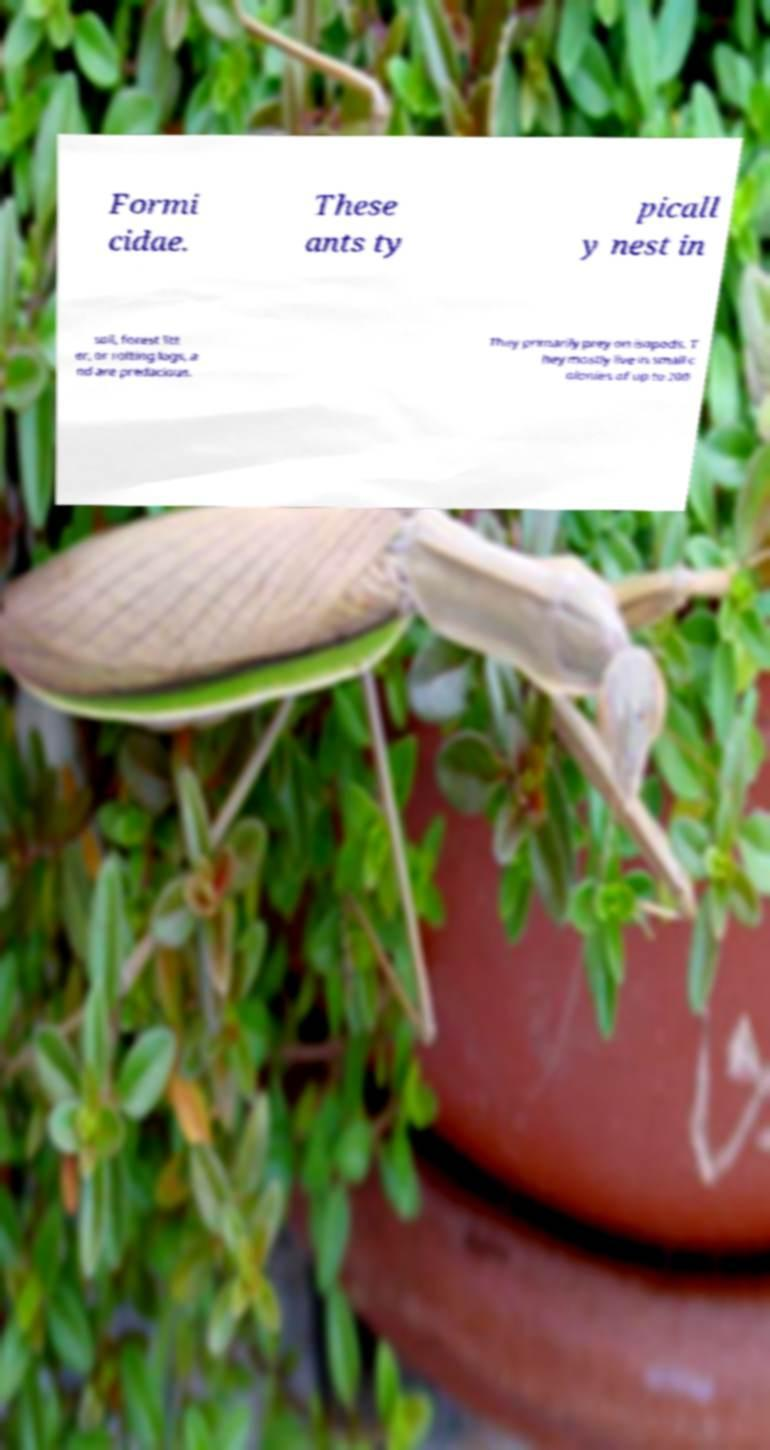Could you extract and type out the text from this image? Formi cidae. These ants ty picall y nest in soil, forest litt er, or rotting logs, a nd are predacious. They primarily prey on isopods. T hey mostly live in small c olonies of up to 200 